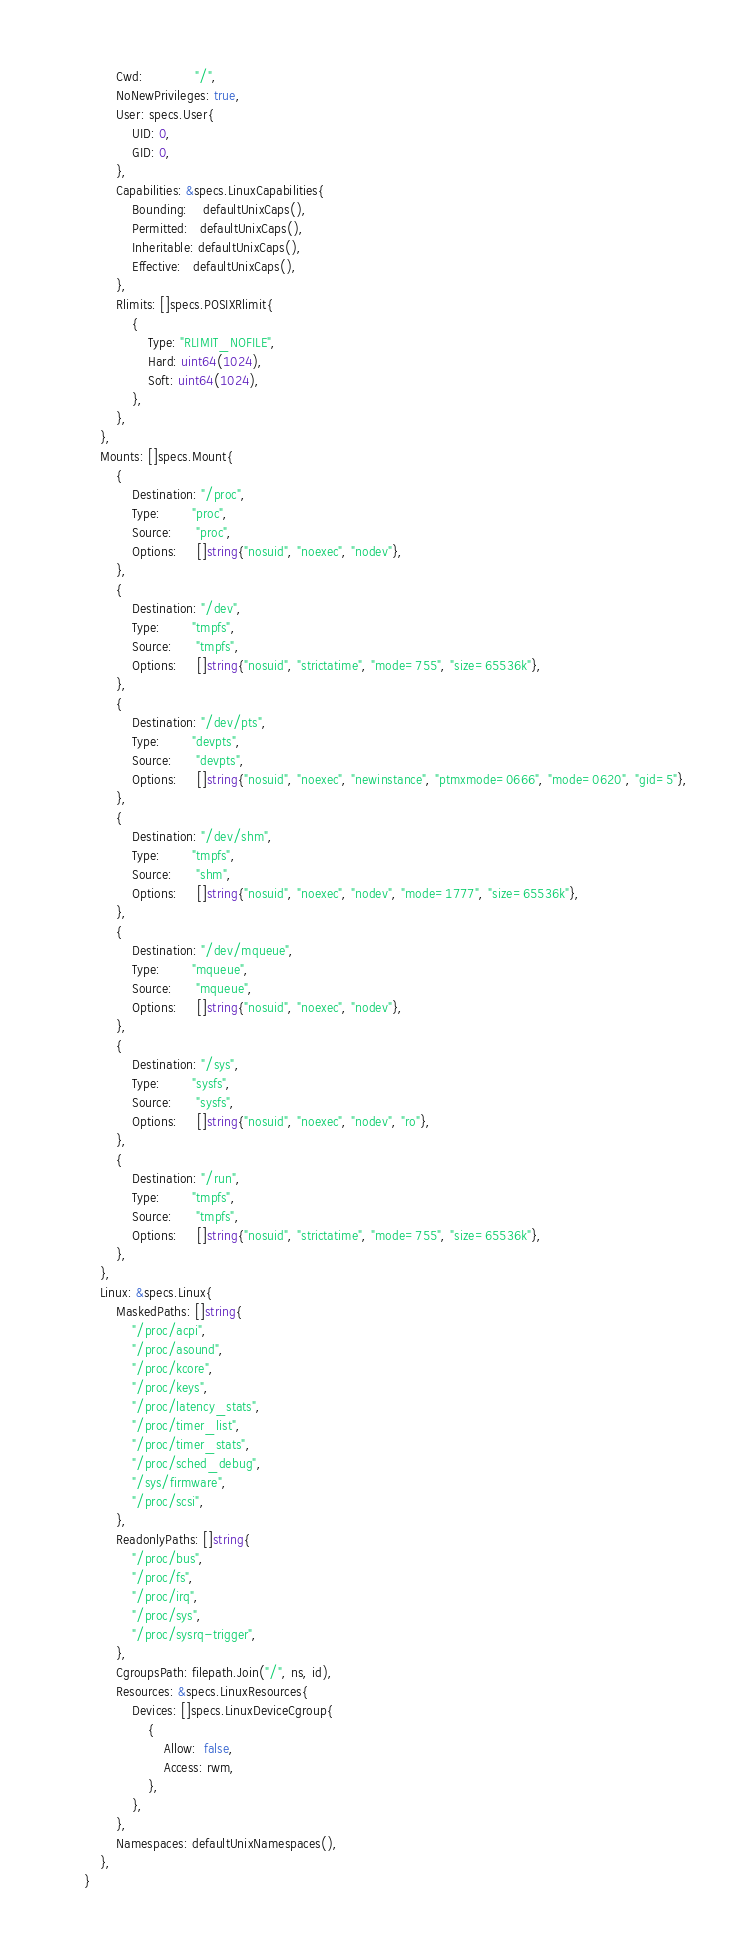Convert code to text. <code><loc_0><loc_0><loc_500><loc_500><_Go_>			Cwd:             "/",
			NoNewPrivileges: true,
			User: specs.User{
				UID: 0,
				GID: 0,
			},
			Capabilities: &specs.LinuxCapabilities{
				Bounding:    defaultUnixCaps(),
				Permitted:   defaultUnixCaps(),
				Inheritable: defaultUnixCaps(),
				Effective:   defaultUnixCaps(),
			},
			Rlimits: []specs.POSIXRlimit{
				{
					Type: "RLIMIT_NOFILE",
					Hard: uint64(1024),
					Soft: uint64(1024),
				},
			},
		},
		Mounts: []specs.Mount{
			{
				Destination: "/proc",
				Type:        "proc",
				Source:      "proc",
				Options:     []string{"nosuid", "noexec", "nodev"},
			},
			{
				Destination: "/dev",
				Type:        "tmpfs",
				Source:      "tmpfs",
				Options:     []string{"nosuid", "strictatime", "mode=755", "size=65536k"},
			},
			{
				Destination: "/dev/pts",
				Type:        "devpts",
				Source:      "devpts",
				Options:     []string{"nosuid", "noexec", "newinstance", "ptmxmode=0666", "mode=0620", "gid=5"},
			},
			{
				Destination: "/dev/shm",
				Type:        "tmpfs",
				Source:      "shm",
				Options:     []string{"nosuid", "noexec", "nodev", "mode=1777", "size=65536k"},
			},
			{
				Destination: "/dev/mqueue",
				Type:        "mqueue",
				Source:      "mqueue",
				Options:     []string{"nosuid", "noexec", "nodev"},
			},
			{
				Destination: "/sys",
				Type:        "sysfs",
				Source:      "sysfs",
				Options:     []string{"nosuid", "noexec", "nodev", "ro"},
			},
			{
				Destination: "/run",
				Type:        "tmpfs",
				Source:      "tmpfs",
				Options:     []string{"nosuid", "strictatime", "mode=755", "size=65536k"},
			},
		},
		Linux: &specs.Linux{
			MaskedPaths: []string{
				"/proc/acpi",
				"/proc/asound",
				"/proc/kcore",
				"/proc/keys",
				"/proc/latency_stats",
				"/proc/timer_list",
				"/proc/timer_stats",
				"/proc/sched_debug",
				"/sys/firmware",
				"/proc/scsi",
			},
			ReadonlyPaths: []string{
				"/proc/bus",
				"/proc/fs",
				"/proc/irq",
				"/proc/sys",
				"/proc/sysrq-trigger",
			},
			CgroupsPath: filepath.Join("/", ns, id),
			Resources: &specs.LinuxResources{
				Devices: []specs.LinuxDeviceCgroup{
					{
						Allow:  false,
						Access: rwm,
					},
				},
			},
			Namespaces: defaultUnixNamespaces(),
		},
	}</code> 